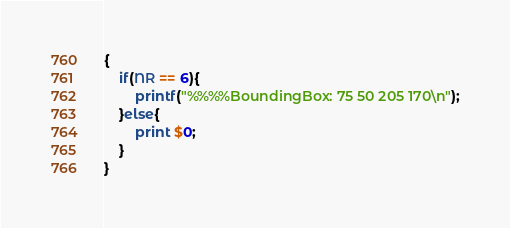Convert code to text. <code><loc_0><loc_0><loc_500><loc_500><_Awk_>{
    if(NR == 6){
        printf("%%%%BoundingBox: 75 50 205 170\n");
    }else{
        print $0;
    }
}
</code> 